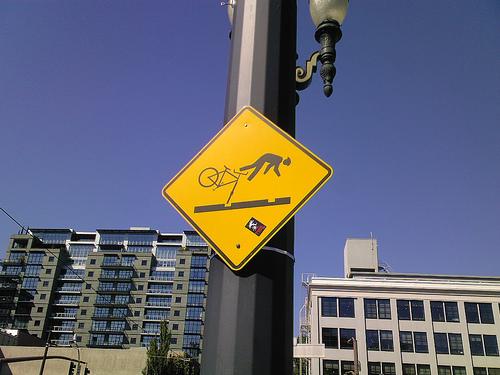How many floors does the hotel have?
Give a very brief answer. 10. Is this a funny sign?
Keep it brief. Yes. What is the yellow sign saying?
Be succinct. Caution,holes in road. What kind of building is to the back left?
Write a very short answer. Apartment. 